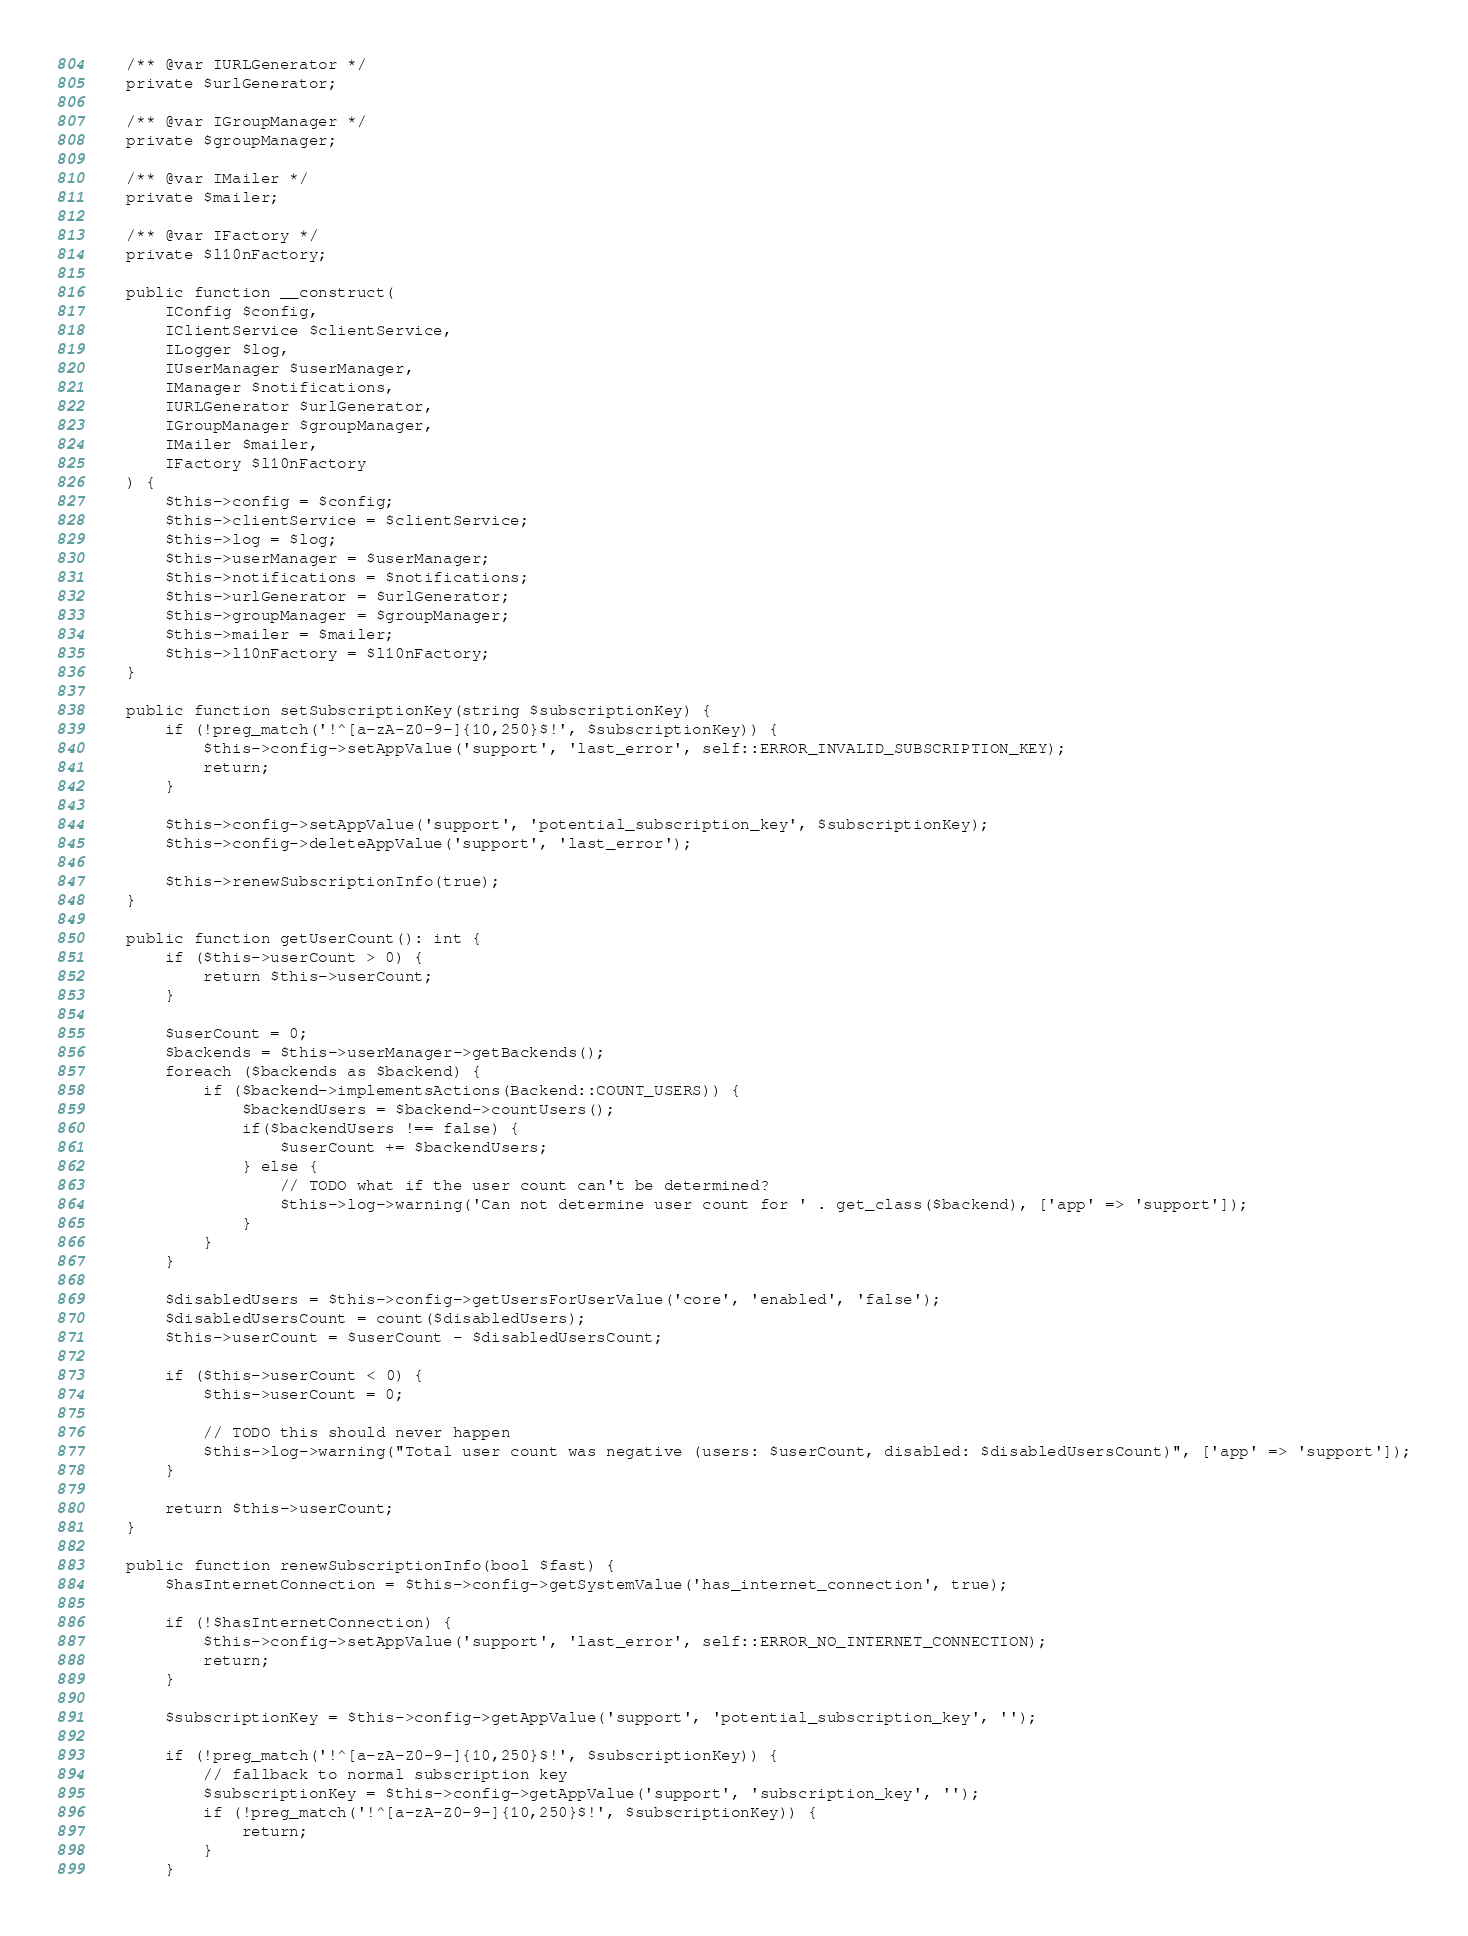Convert code to text. <code><loc_0><loc_0><loc_500><loc_500><_PHP_>	/** @var IURLGenerator */
	private $urlGenerator;

	/** @var IGroupManager */
	private $groupManager;

	/** @var IMailer */
	private $mailer;

	/** @var IFactory */
	private $l10nFactory;

	public function __construct(
		IConfig $config,
		IClientService $clientService,
		ILogger $log,
		IUserManager $userManager,
		IManager $notifications,
		IURLGenerator $urlGenerator,
		IGroupManager $groupManager,
		IMailer $mailer,
		IFactory $l10nFactory
	) {
		$this->config = $config;
		$this->clientService = $clientService;
		$this->log = $log;
		$this->userManager = $userManager;
		$this->notifications = $notifications;
		$this->urlGenerator = $urlGenerator;
		$this->groupManager = $groupManager;
		$this->mailer = $mailer;
		$this->l10nFactory = $l10nFactory;
	}

	public function setSubscriptionKey(string $subscriptionKey) {
		if (!preg_match('!^[a-zA-Z0-9-]{10,250}$!', $subscriptionKey)) {
			$this->config->setAppValue('support', 'last_error', self::ERROR_INVALID_SUBSCRIPTION_KEY);
			return;
		}

		$this->config->setAppValue('support', 'potential_subscription_key', $subscriptionKey);
		$this->config->deleteAppValue('support', 'last_error');

		$this->renewSubscriptionInfo(true);
	}

	public function getUserCount(): int {
		if ($this->userCount > 0) {
			return $this->userCount;
		}

		$userCount = 0;
		$backends = $this->userManager->getBackends();
		foreach ($backends as $backend) {
			if ($backend->implementsActions(Backend::COUNT_USERS)) {
				$backendUsers = $backend->countUsers();
				if($backendUsers !== false) {
					$userCount += $backendUsers;
				} else {
					// TODO what if the user count can't be determined?
					$this->log->warning('Can not determine user count for ' . get_class($backend), ['app' => 'support']);
				}
			}
		}

		$disabledUsers = $this->config->getUsersForUserValue('core', 'enabled', 'false');
		$disabledUsersCount = count($disabledUsers);
		$this->userCount = $userCount - $disabledUsersCount;

		if ($this->userCount < 0) {
			$this->userCount = 0;

			// TODO this should never happen
			$this->log->warning("Total user count was negative (users: $userCount, disabled: $disabledUsersCount)", ['app' => 'support']);
		}

		return $this->userCount;
	}

	public function renewSubscriptionInfo(bool $fast) {
		$hasInternetConnection = $this->config->getSystemValue('has_internet_connection', true);

		if (!$hasInternetConnection) {
			$this->config->setAppValue('support', 'last_error', self::ERROR_NO_INTERNET_CONNECTION);
			return;
		}

		$subscriptionKey = $this->config->getAppValue('support', 'potential_subscription_key', '');

		if (!preg_match('!^[a-zA-Z0-9-]{10,250}$!', $subscriptionKey)) {
			// fallback to normal subscription key
			$subscriptionKey = $this->config->getAppValue('support', 'subscription_key', '');
			if (!preg_match('!^[a-zA-Z0-9-]{10,250}$!', $subscriptionKey)) {
				return;
			}
		}
</code> 